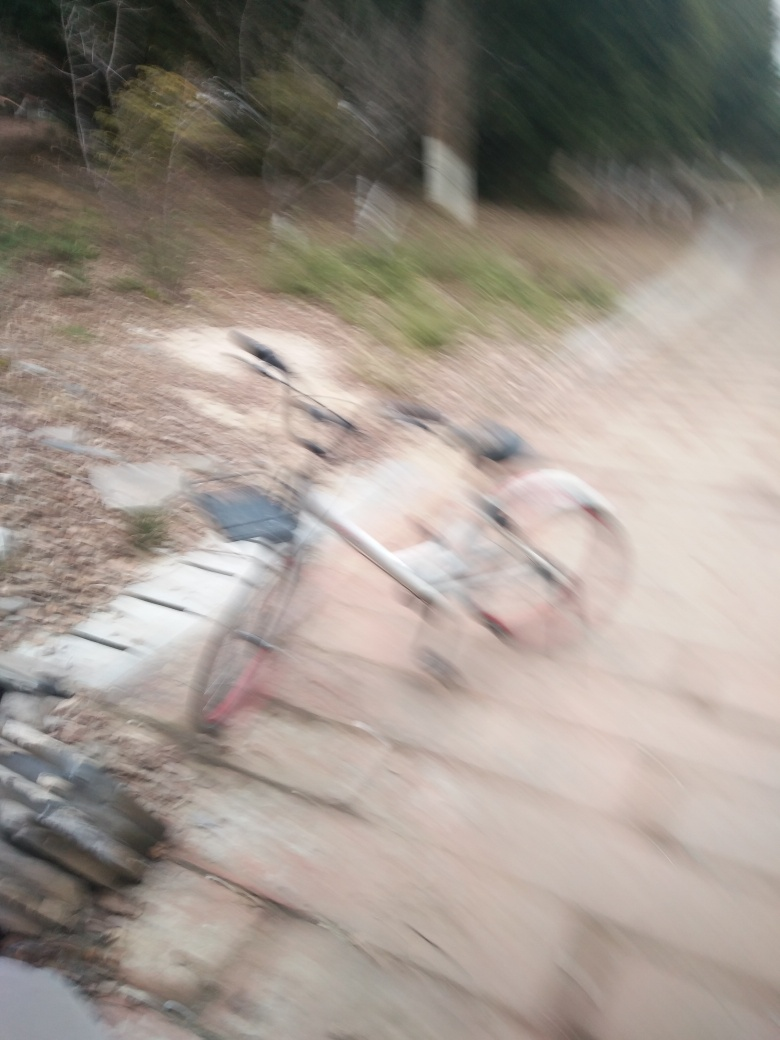Describe any objects or subjects you can identify in this blurred image. Despite the blurriness, we can discern the form of a bicycle lying on the ground, tilted to its side. The shape of the wheels, frame, and handlebars are still recognizable. The surroundings are less clear, but it appears to be an outdoor setting with elements of nature and a pathway or road. The exact details, such as the type of bicycle or the specific location, are obscured by the photo's low clarity. 